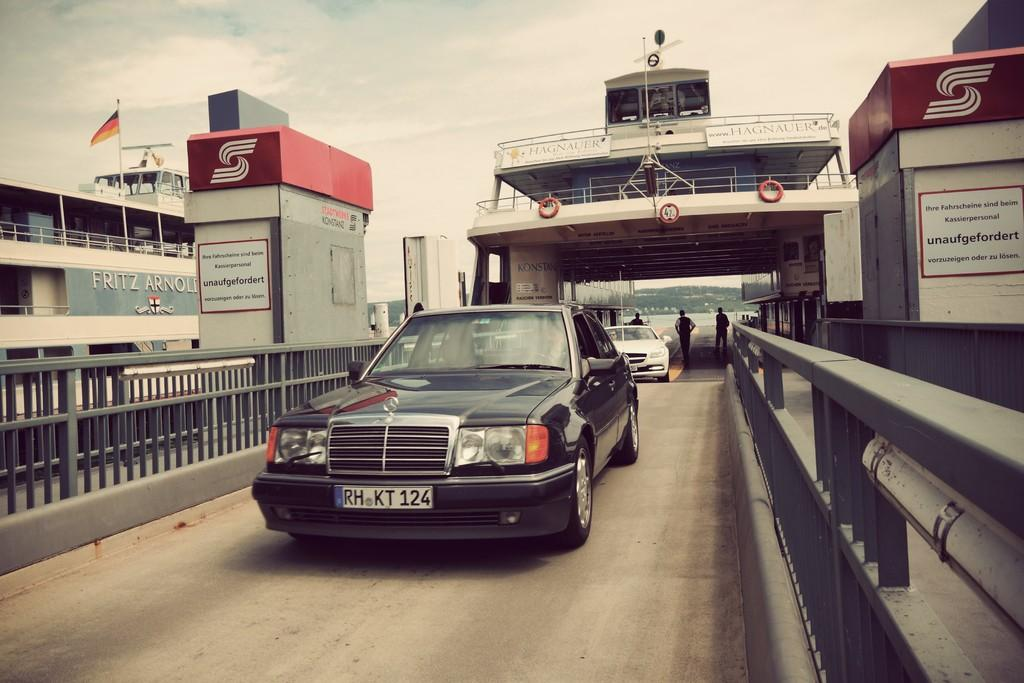What colors are the vehicles in the image? There is a black vehicle and a white vehicle in the image. What is happening behind the white vehicle? There are three people behind the white vehicle. What additional objects can be seen in the image? There is a flag, tubes, and boards in the image. What is the condition of the sky in the image? The sky is cloudy in the image. How many bags of feed are visible for the pigs in the image? There are no pigs or bags of feed present in the image. What type of ducks can be seen swimming in the water in the image? There is no water or ducks present in the image. 